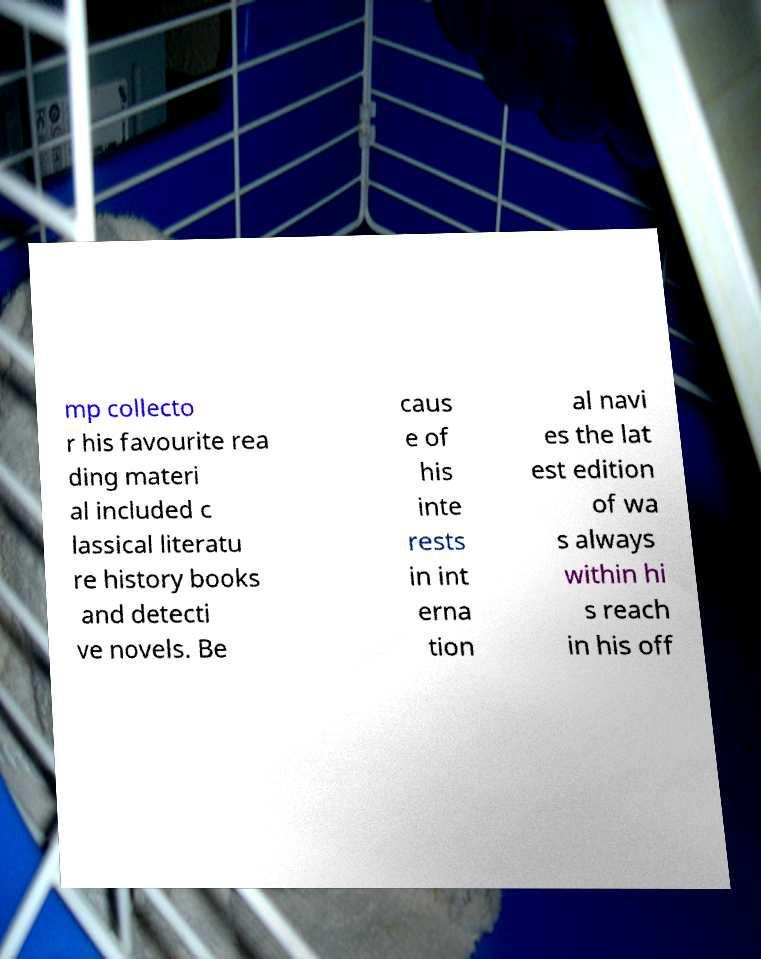Please read and relay the text visible in this image. What does it say? mp collecto r his favourite rea ding materi al included c lassical literatu re history books and detecti ve novels. Be caus e of his inte rests in int erna tion al navi es the lat est edition of wa s always within hi s reach in his off 